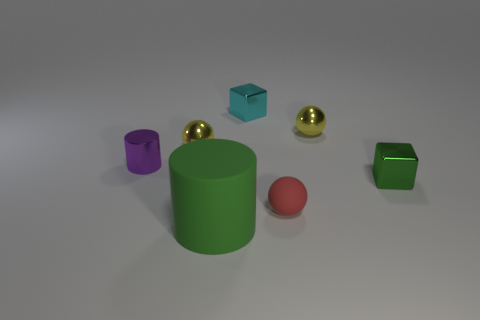Subtract all tiny metal spheres. How many spheres are left? 1 Subtract all cylinders. How many objects are left? 5 Add 1 rubber objects. How many objects exist? 8 Subtract all green cylinders. How many cylinders are left? 1 Subtract 2 balls. How many balls are left? 1 Subtract all cyan cylinders. Subtract all blue balls. How many cylinders are left? 2 Subtract all blue balls. How many red cylinders are left? 0 Subtract all tiny green things. Subtract all green matte things. How many objects are left? 5 Add 2 red balls. How many red balls are left? 3 Add 2 tiny spheres. How many tiny spheres exist? 5 